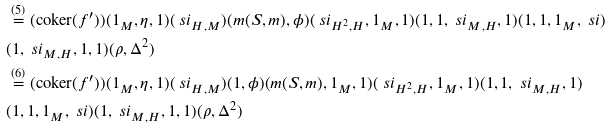Convert formula to latex. <formula><loc_0><loc_0><loc_500><loc_500>& \overset { ( 5 ) } { = } ( \text {coker} ( f ^ { \prime } ) ) ( 1 _ { M } , \eta , 1 ) ( \ s i _ { H , M } ) ( m ( S , m ) , \phi ) ( \ s i _ { H ^ { 2 } , H } , 1 _ { M } , 1 ) ( 1 , 1 , \ s i _ { M , H } , 1 ) ( 1 , 1 , 1 _ { M } , \ s i ) & \\ & ( 1 , \ s i _ { M , H } , 1 , 1 ) ( \rho , \Delta ^ { 2 } ) & \\ & \overset { ( 6 ) } { = } ( \text {coker} ( f ^ { \prime } ) ) ( 1 _ { M } , \eta , 1 ) ( \ s i _ { H , M } ) ( 1 , \phi ) ( m ( S , m ) , 1 _ { M } , 1 ) ( \ s i _ { H ^ { 2 } , H } , 1 _ { M } , 1 ) ( 1 , 1 , \ s i _ { M , H } , 1 ) & \\ & ( 1 , 1 , 1 _ { M } , \ s i ) ( 1 , \ s i _ { M , H } , 1 , 1 ) ( \rho , \Delta ^ { 2 } ) & \\</formula> 